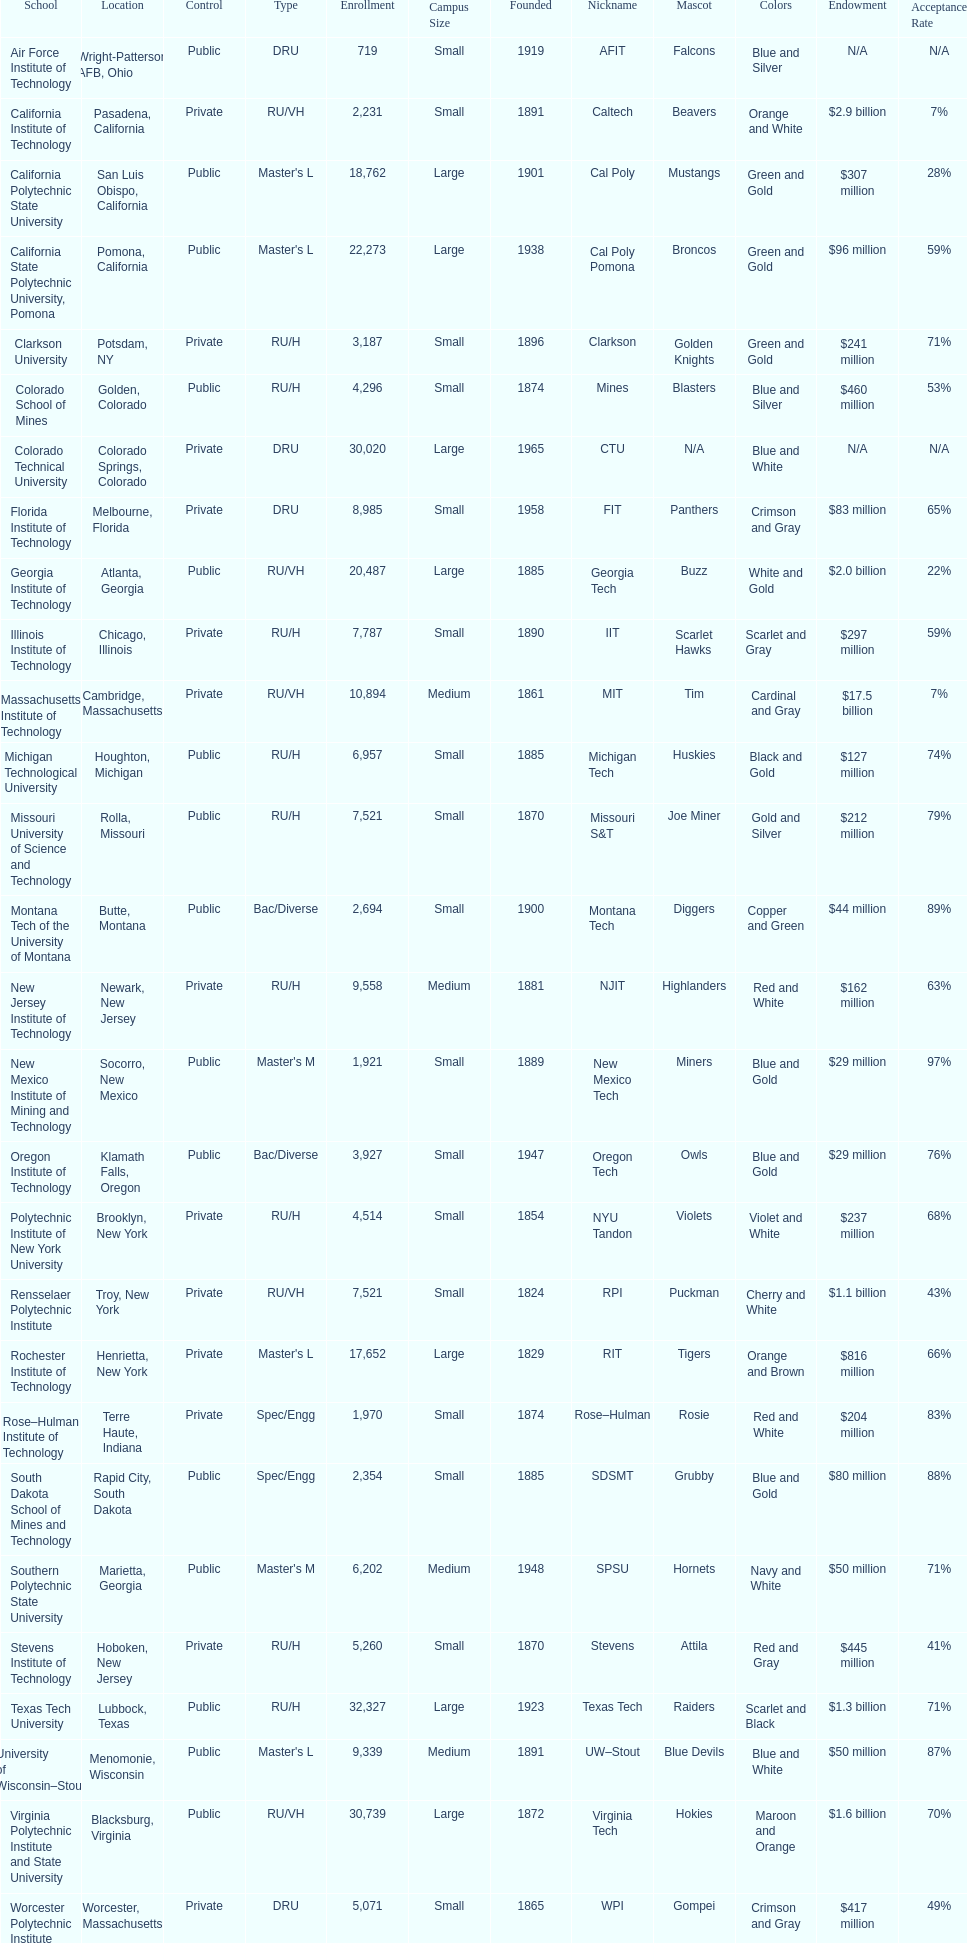What's the number of schools represented in the table? 28. 